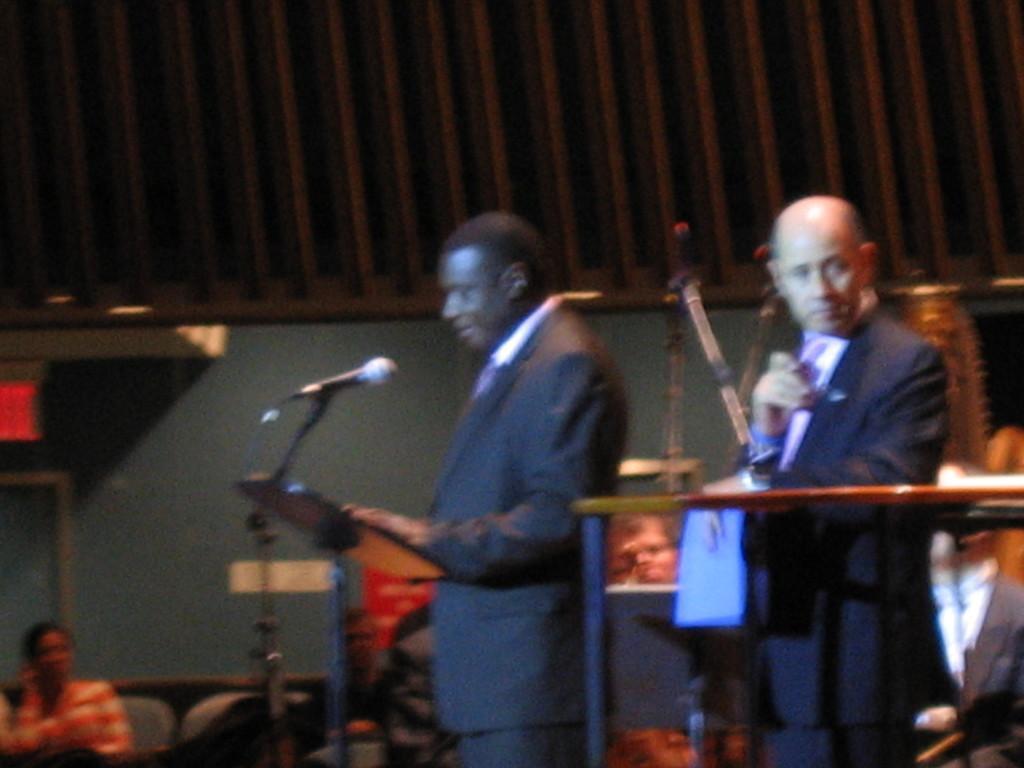Could you give a brief overview of what you see in this image? In this picture there are two persons wearing suits and standing and there is a mic in front of them and there is another person in the left corner. 